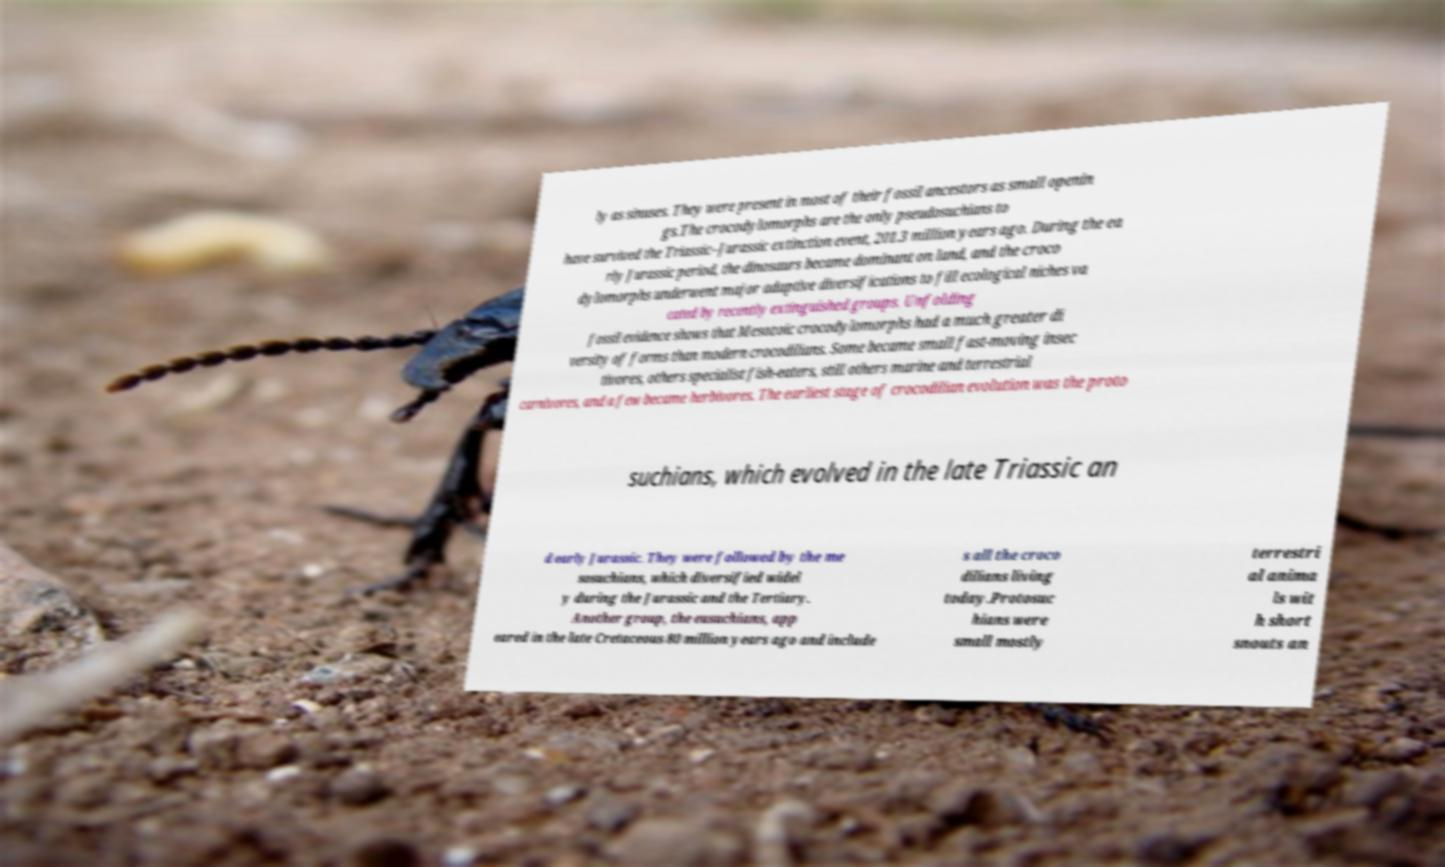Could you assist in decoding the text presented in this image and type it out clearly? ly as sinuses. They were present in most of their fossil ancestors as small openin gs.The crocodylomorphs are the only pseudosuchians to have survived the Triassic–Jurassic extinction event, 201.3 million years ago. During the ea rly Jurassic period, the dinosaurs became dominant on land, and the croco dylomorphs underwent major adaptive diversifications to fill ecological niches va cated by recently extinguished groups. Unfolding fossil evidence shows that Mesozoic crocodylomorphs had a much greater di versity of forms than modern crocodilians. Some became small fast-moving insec tivores, others specialist fish-eaters, still others marine and terrestrial carnivores, and a few became herbivores. The earliest stage of crocodilian evolution was the proto suchians, which evolved in the late Triassic an d early Jurassic. They were followed by the me sosuchians, which diversified widel y during the Jurassic and the Tertiary. Another group, the eusuchians, app eared in the late Cretaceous 80 million years ago and include s all the croco dilians living today.Protosuc hians were small mostly terrestri al anima ls wit h short snouts an 